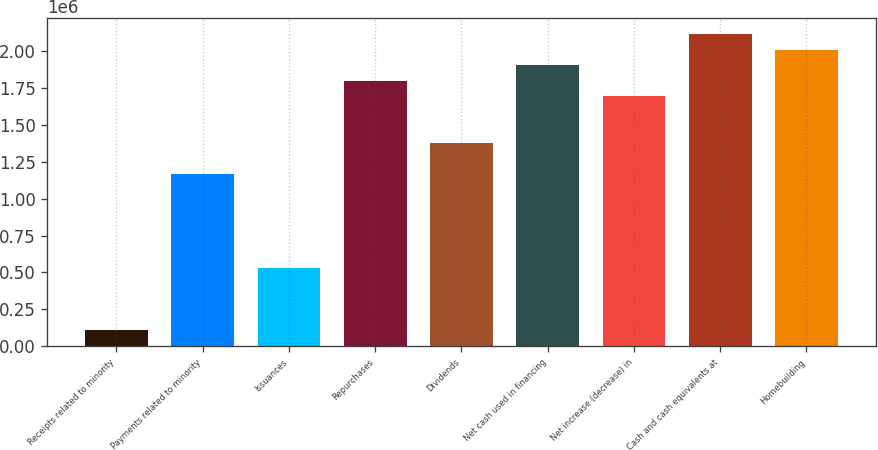<chart> <loc_0><loc_0><loc_500><loc_500><bar_chart><fcel>Receipts related to minority<fcel>Payments related to minority<fcel>Issuances<fcel>Repurchases<fcel>Dividends<fcel>Net cash used in financing<fcel>Net increase (decrease) in<fcel>Cash and cash equivalents at<fcel>Homebuilding<nl><fcel>106143<fcel>1.16525e+06<fcel>529788<fcel>1.80072e+06<fcel>1.37708e+06<fcel>1.90663e+06<fcel>1.69481e+06<fcel>2.11845e+06<fcel>2.01254e+06<nl></chart> 